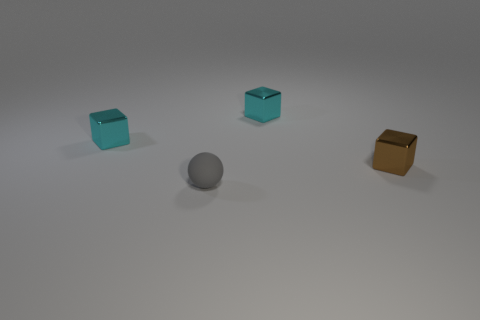How many things are small objects behind the brown thing or tiny things that are on the left side of the tiny gray thing?
Make the answer very short. 2. Are there more small spheres that are in front of the gray object than small matte objects?
Your answer should be compact. No. How many brown matte blocks are the same size as the brown metal object?
Provide a succinct answer. 0. Does the cyan metal block that is to the left of the tiny gray thing have the same size as the cyan metallic thing right of the tiny gray ball?
Ensure brevity in your answer.  Yes. What is the size of the shiny thing on the left side of the tiny gray rubber object?
Provide a succinct answer. Small. What size is the cyan thing that is behind the small cyan shiny cube on the left side of the sphere?
Your response must be concise. Small. There is a gray thing that is the same size as the brown object; what is its material?
Keep it short and to the point. Rubber. There is a tiny rubber thing; are there any shiny blocks behind it?
Keep it short and to the point. Yes. Is the number of cubes behind the ball the same as the number of gray blocks?
Ensure brevity in your answer.  No. The brown object that is the same size as the gray ball is what shape?
Keep it short and to the point. Cube. 